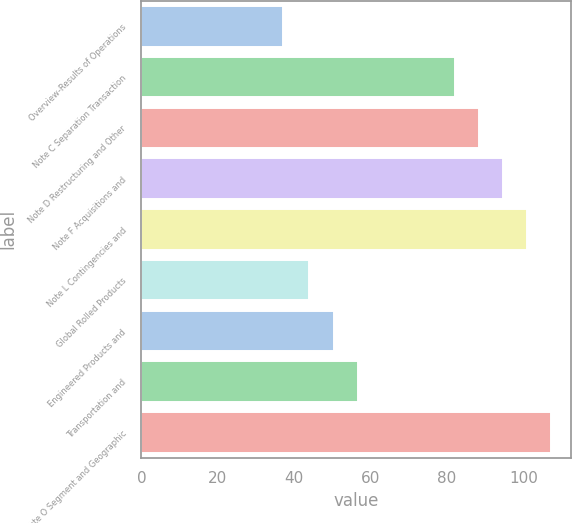Convert chart. <chart><loc_0><loc_0><loc_500><loc_500><bar_chart><fcel>Overview-Results of Operations<fcel>Note C Separation Transaction<fcel>Note D Restructuring and Other<fcel>Note F Acquisitions and<fcel>Note L Contingencies and<fcel>Global Rolled Products<fcel>Engineered Products and<fcel>Transportation and<fcel>Note O Segment and Geographic<nl><fcel>37<fcel>82<fcel>88.3<fcel>94.6<fcel>100.9<fcel>44<fcel>50.3<fcel>56.6<fcel>107.2<nl></chart> 